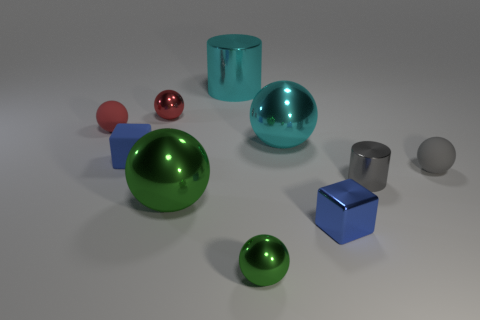Subtract all gray spheres. How many spheres are left? 5 Subtract all tiny metal balls. How many balls are left? 4 Subtract all gray spheres. Subtract all green cylinders. How many spheres are left? 5 Subtract all spheres. How many objects are left? 4 Add 2 green matte cylinders. How many green matte cylinders exist? 2 Subtract 1 cyan cylinders. How many objects are left? 9 Subtract all small blocks. Subtract all brown metal cylinders. How many objects are left? 8 Add 2 blue matte objects. How many blue matte objects are left? 3 